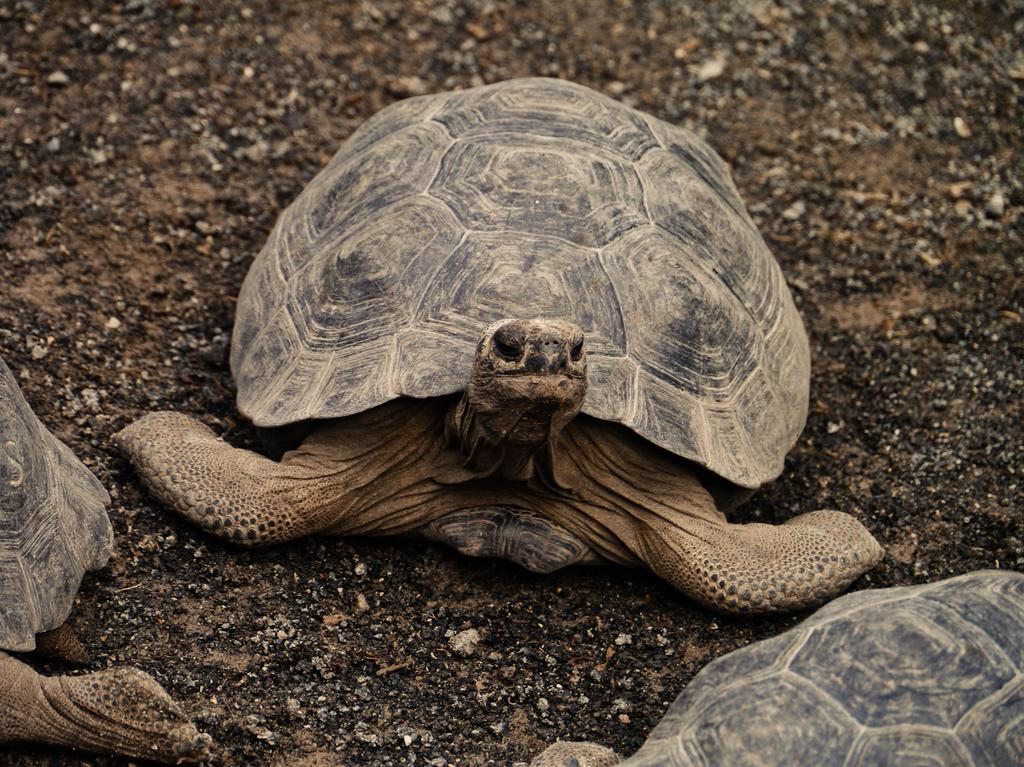What type of animals are in the image? There are tortoises in the image. Where are the tortoises located? The tortoises are on the ground. What type of cart can be seen carrying the jelly in the image? There is no cart or jelly present in the image; it only features tortoises on the ground. 